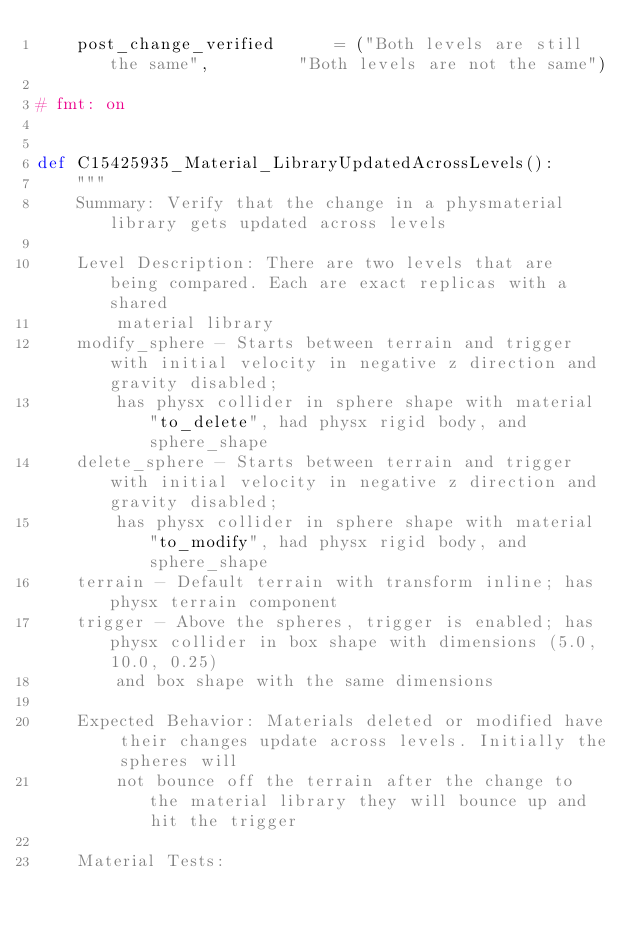<code> <loc_0><loc_0><loc_500><loc_500><_Python_>    post_change_verified      = ("Both levels are still the same",         "Both levels are not the same")

# fmt: on


def C15425935_Material_LibraryUpdatedAcrossLevels():
    """
    Summary: Verify that the change in a physmaterial library gets updated across levels

    Level Description: There are two levels that are being compared. Each are exact replicas with a shared
        material library
    modify_sphere - Starts between terrain and trigger with initial velocity in negative z direction and gravity disabled;
        has physx collider in sphere shape with material "to_delete", had physx rigid body, and sphere_shape
    delete_sphere - Starts between terrain and trigger with initial velocity in negative z direction and gravity disabled;
        has physx collider in sphere shape with material "to_modify", had physx rigid body, and sphere_shape
    terrain - Default terrain with transform inline; has physx terrain component
    trigger - Above the spheres, trigger is enabled; has physx collider in box shape with dimensions (5.0, 10.0, 0.25)
        and box shape with the same dimensions

    Expected Behavior: Materials deleted or modified have their changes update across levels. Initially the spheres will
        not bounce off the terrain after the change to the material library they will bounce up and hit the trigger

    Material Tests:</code> 